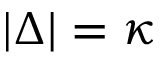<formula> <loc_0><loc_0><loc_500><loc_500>| \Delta | = \kappa</formula> 